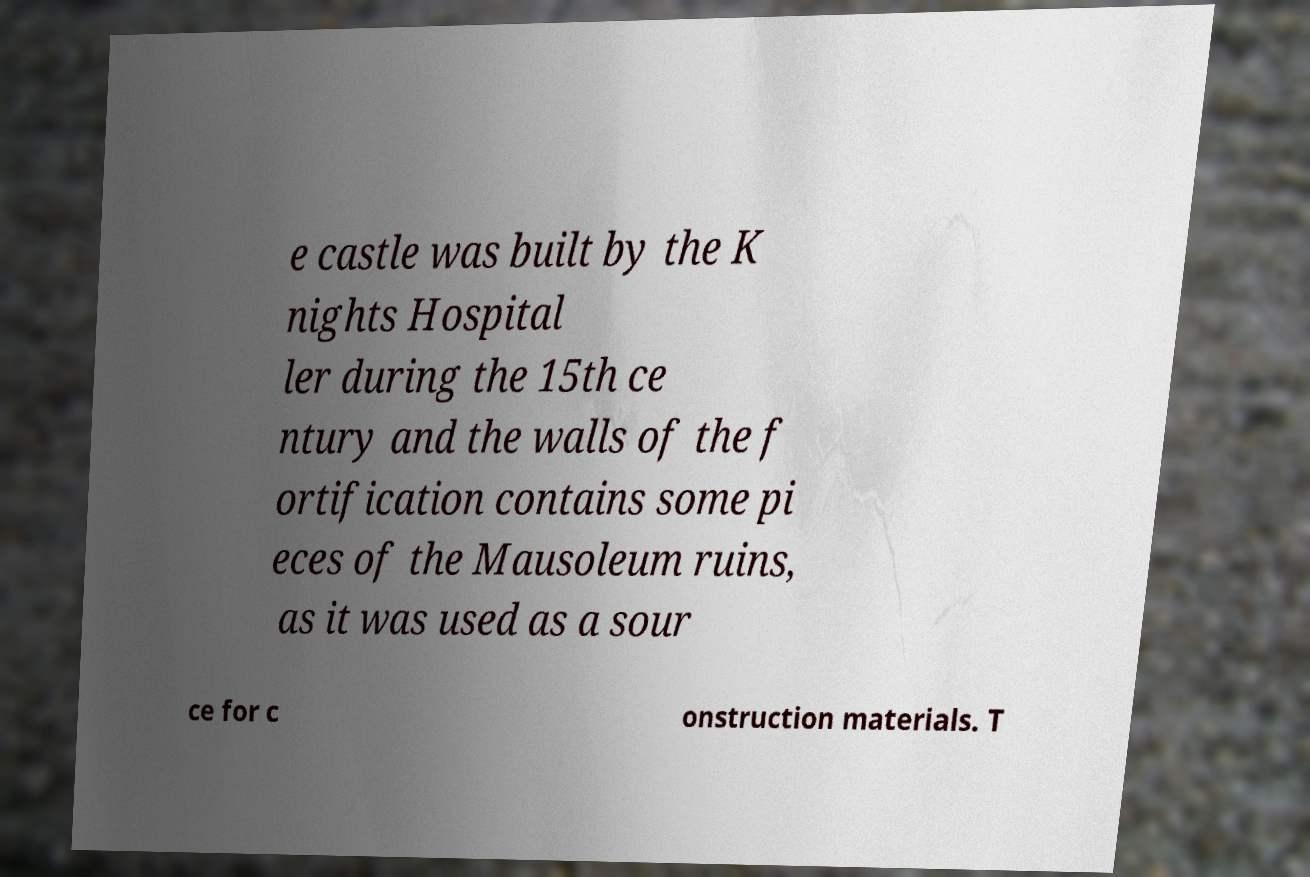There's text embedded in this image that I need extracted. Can you transcribe it verbatim? e castle was built by the K nights Hospital ler during the 15th ce ntury and the walls of the f ortification contains some pi eces of the Mausoleum ruins, as it was used as a sour ce for c onstruction materials. T 